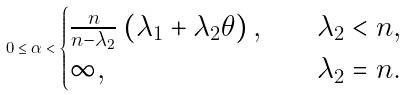Convert formula to latex. <formula><loc_0><loc_0><loc_500><loc_500>0 \leq \alpha < \begin{cases} \frac { n } { n - \lambda _ { 2 } } \left ( \lambda _ { 1 } + \lambda _ { 2 } \theta \right ) , & \quad \lambda _ { 2 } < n , \\ \infty , & \quad \lambda _ { 2 } = n . \end{cases}</formula> 